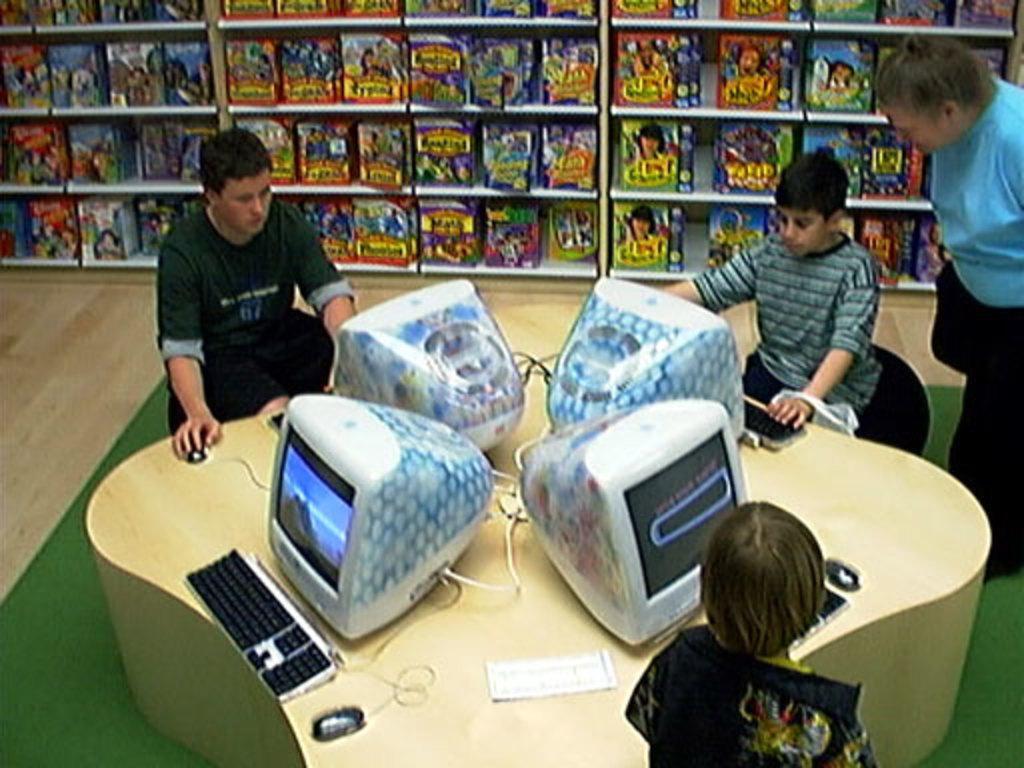How would you summarize this image in a sentence or two? In the image we can see there are kids sitting on the chair and on the table there are monitors. There is a person standing and behind there are books kept in a shelf. 